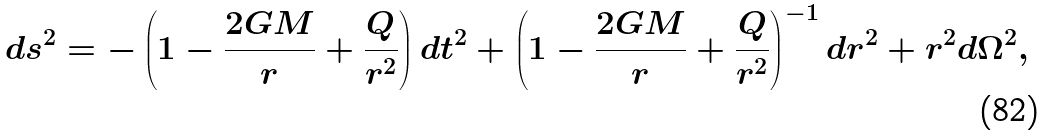Convert formula to latex. <formula><loc_0><loc_0><loc_500><loc_500>d s ^ { 2 } = - \left ( 1 - \frac { 2 G M } { r } + \frac { Q } { r ^ { 2 } } \right ) d t ^ { 2 } + \left ( 1 - \frac { 2 G M } { r } + \frac { Q } { r ^ { 2 } } \right ) ^ { - 1 } d r ^ { 2 } + r ^ { 2 } d \Omega ^ { 2 } ,</formula> 